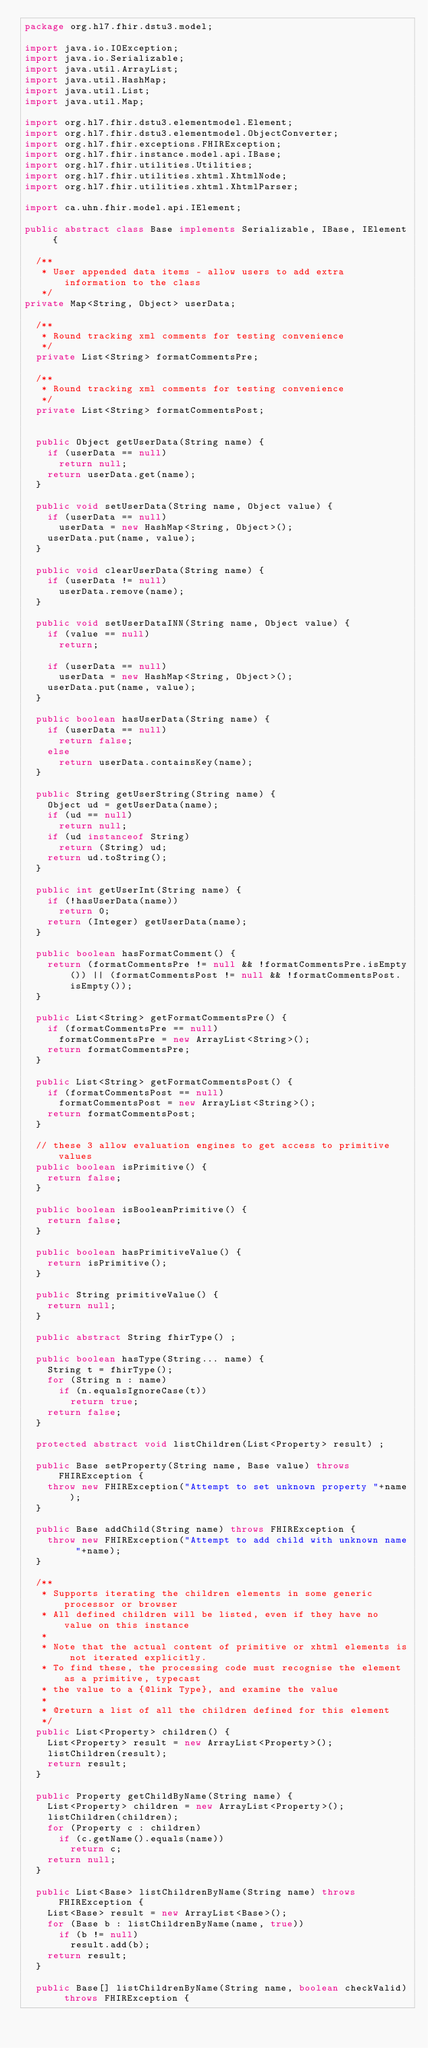<code> <loc_0><loc_0><loc_500><loc_500><_Java_>package org.hl7.fhir.dstu3.model;

import java.io.IOException;
import java.io.Serializable;
import java.util.ArrayList;
import java.util.HashMap;
import java.util.List;
import java.util.Map;

import org.hl7.fhir.dstu3.elementmodel.Element;
import org.hl7.fhir.dstu3.elementmodel.ObjectConverter;
import org.hl7.fhir.exceptions.FHIRException;
import org.hl7.fhir.instance.model.api.IBase;
import org.hl7.fhir.utilities.Utilities;
import org.hl7.fhir.utilities.xhtml.XhtmlNode;
import org.hl7.fhir.utilities.xhtml.XhtmlParser;

import ca.uhn.fhir.model.api.IElement;

public abstract class Base implements Serializable, IBase, IElement {

  /**
   * User appended data items - allow users to add extra information to the class
   */
private Map<String, Object> userData; 

  /**
   * Round tracking xml comments for testing convenience
   */
  private List<String> formatCommentsPre; 
   
  /**
   * Round tracking xml comments for testing convenience
   */
  private List<String> formatCommentsPost; 
   
  
  public Object getUserData(String name) {
    if (userData == null)
      return null;
    return userData.get(name);
  }
  
  public void setUserData(String name, Object value) {
    if (userData == null)
      userData = new HashMap<String, Object>();
    userData.put(name, value);
  }

  public void clearUserData(String name) {
    if (userData != null)
      userData.remove(name);
  }
  
  public void setUserDataINN(String name, Object value) {
    if (value == null)
      return;
    
    if (userData == null)
      userData = new HashMap<String, Object>();
    userData.put(name, value);
  }

  public boolean hasUserData(String name) {
    if (userData == null)
      return false;
    else
      return userData.containsKey(name);
  }

	public String getUserString(String name) {
    Object ud = getUserData(name);
    if (ud == null)
      return null;
    if (ud instanceof String)
      return (String) ud;
    return ud.toString();
  }

  public int getUserInt(String name) {
    if (!hasUserData(name))
      return 0;
    return (Integer) getUserData(name);
  }

  public boolean hasFormatComment() {
  	return (formatCommentsPre != null && !formatCommentsPre.isEmpty()) || (formatCommentsPost != null && !formatCommentsPost.isEmpty());
  }
  
  public List<String> getFormatCommentsPre() {
    if (formatCommentsPre == null)
      formatCommentsPre = new ArrayList<String>();
    return formatCommentsPre;
  }
  
  public List<String> getFormatCommentsPost() {
    if (formatCommentsPost == null)
      formatCommentsPost = new ArrayList<String>();
    return formatCommentsPost;
  }  
  
	// these 3 allow evaluation engines to get access to primitive values
	public boolean isPrimitive() {
		return false;
	}
	
  public boolean isBooleanPrimitive() {
    return false;
  }

	public boolean hasPrimitiveValue() {
		return isPrimitive();
	}
	
	public String primitiveValue() {
		return null;
	}
	
	public abstract String fhirType() ;
	
	public boolean hasType(String... name) {
		String t = fhirType();
		for (String n : name)
		  if (n.equalsIgnoreCase(t))
		  	return true;
		return false;
	}
	
	protected abstract void listChildren(List<Property> result) ;
	
	public Base setProperty(String name, Base value) throws FHIRException {
	  throw new FHIRException("Attempt to set unknown property "+name);
	}
	
	public Base addChild(String name) throws FHIRException {
    throw new FHIRException("Attempt to add child with unknown name "+name);
  }

  /**
   * Supports iterating the children elements in some generic processor or browser
   * All defined children will be listed, even if they have no value on this instance
   * 
   * Note that the actual content of primitive or xhtml elements is not iterated explicitly.
   * To find these, the processing code must recognise the element as a primitive, typecast
   * the value to a {@link Type}, and examine the value
   *  
   * @return a list of all the children defined for this element
   */
  public List<Property> children() {
  	List<Property> result = new ArrayList<Property>();
  	listChildren(result);
  	return result;
  }

  public Property getChildByName(String name) {
    List<Property> children = new ArrayList<Property>();
    listChildren(children);
    for (Property c : children)
      if (c.getName().equals(name))
        return c;
    return null;
  }  
  
  public List<Base> listChildrenByName(String name) throws FHIRException {
    List<Base> result = new ArrayList<Base>();
  	for (Base b : listChildrenByName(name, true))
  		if (b != null)
  		  result.add(b);
    return result;
  }

  public Base[] listChildrenByName(String name, boolean checkValid) throws FHIRException {</code> 